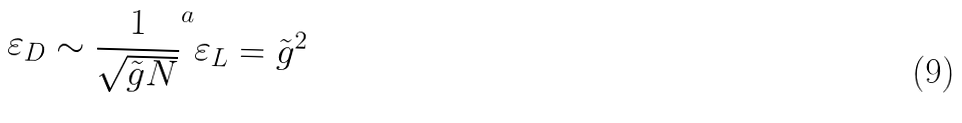<formula> <loc_0><loc_0><loc_500><loc_500>\varepsilon _ { D } \sim \frac { 1 } { \sqrt { \tilde { g } N } } ^ { a } \varepsilon _ { L } = \tilde { g } ^ { 2 }</formula> 